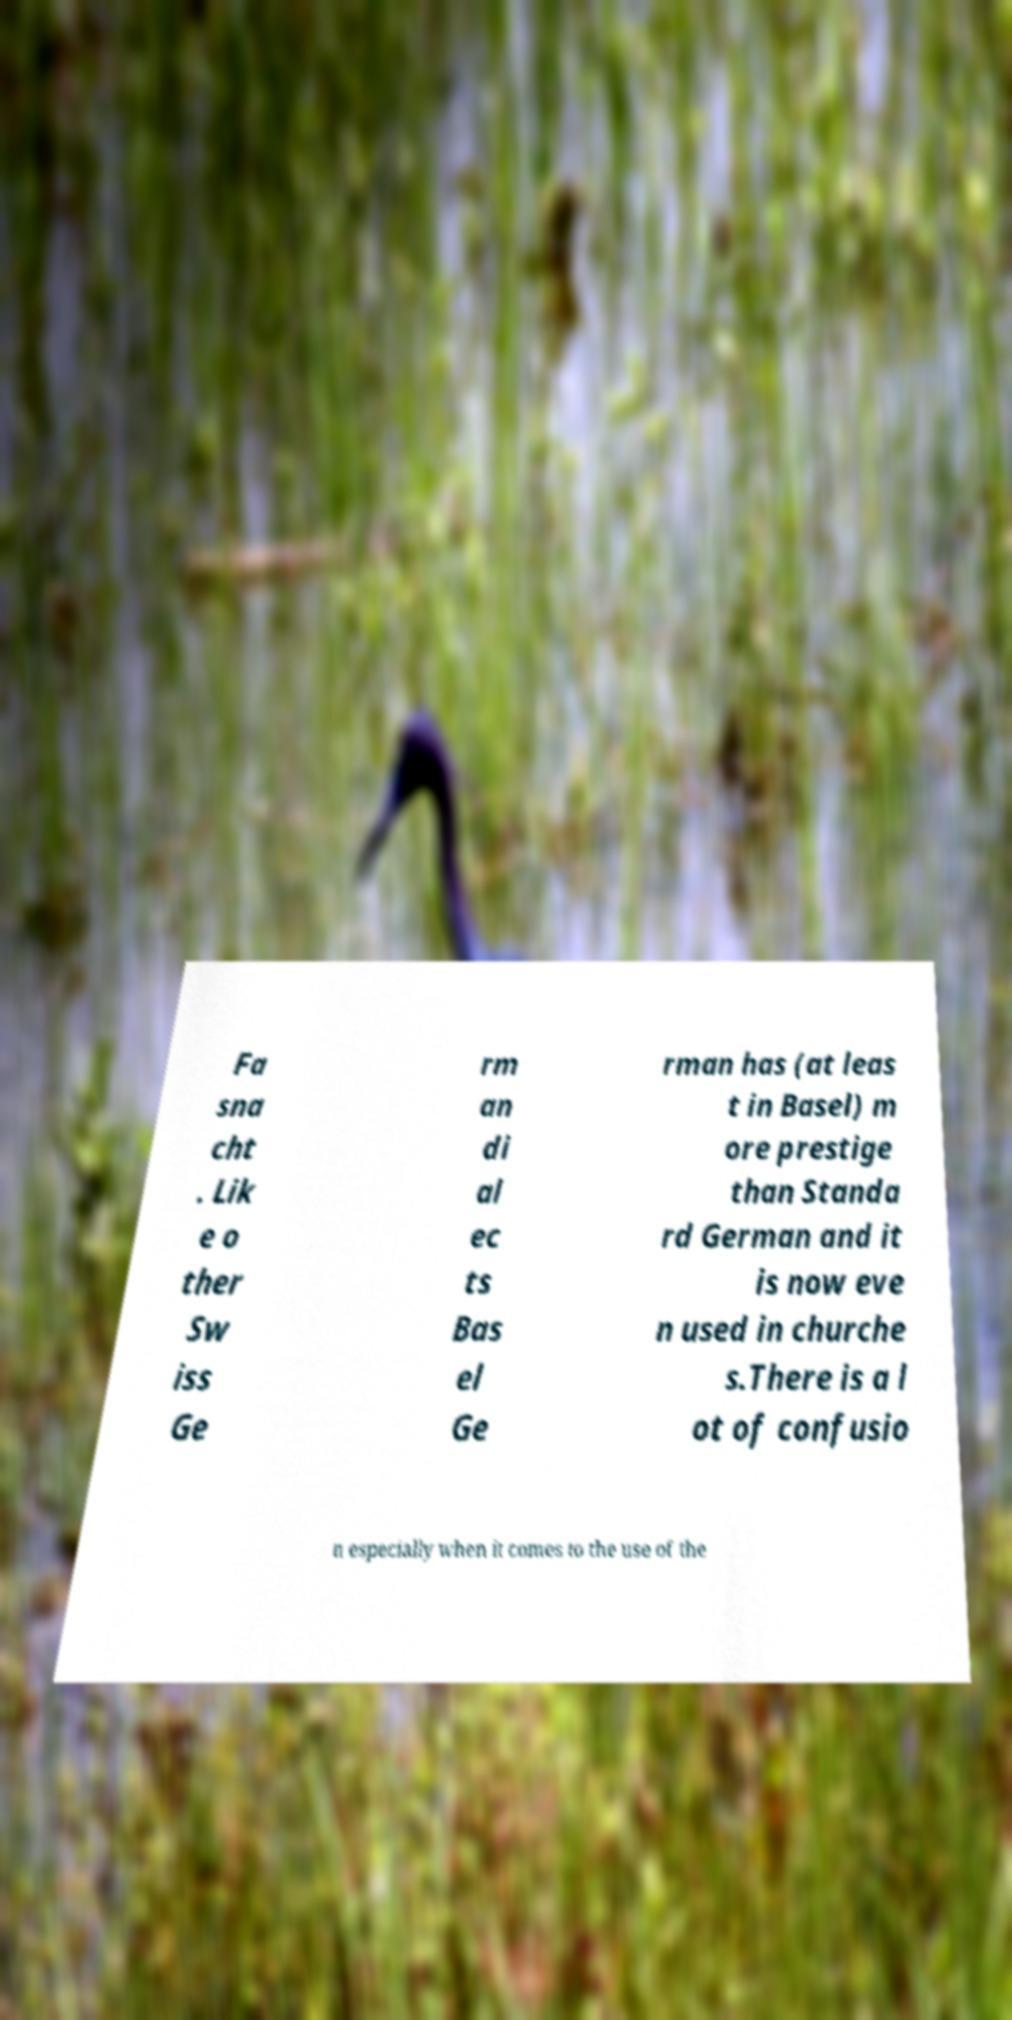Please read and relay the text visible in this image. What does it say? Fa sna cht . Lik e o ther Sw iss Ge rm an di al ec ts Bas el Ge rman has (at leas t in Basel) m ore prestige than Standa rd German and it is now eve n used in churche s.There is a l ot of confusio n especially when it comes to the use of the 